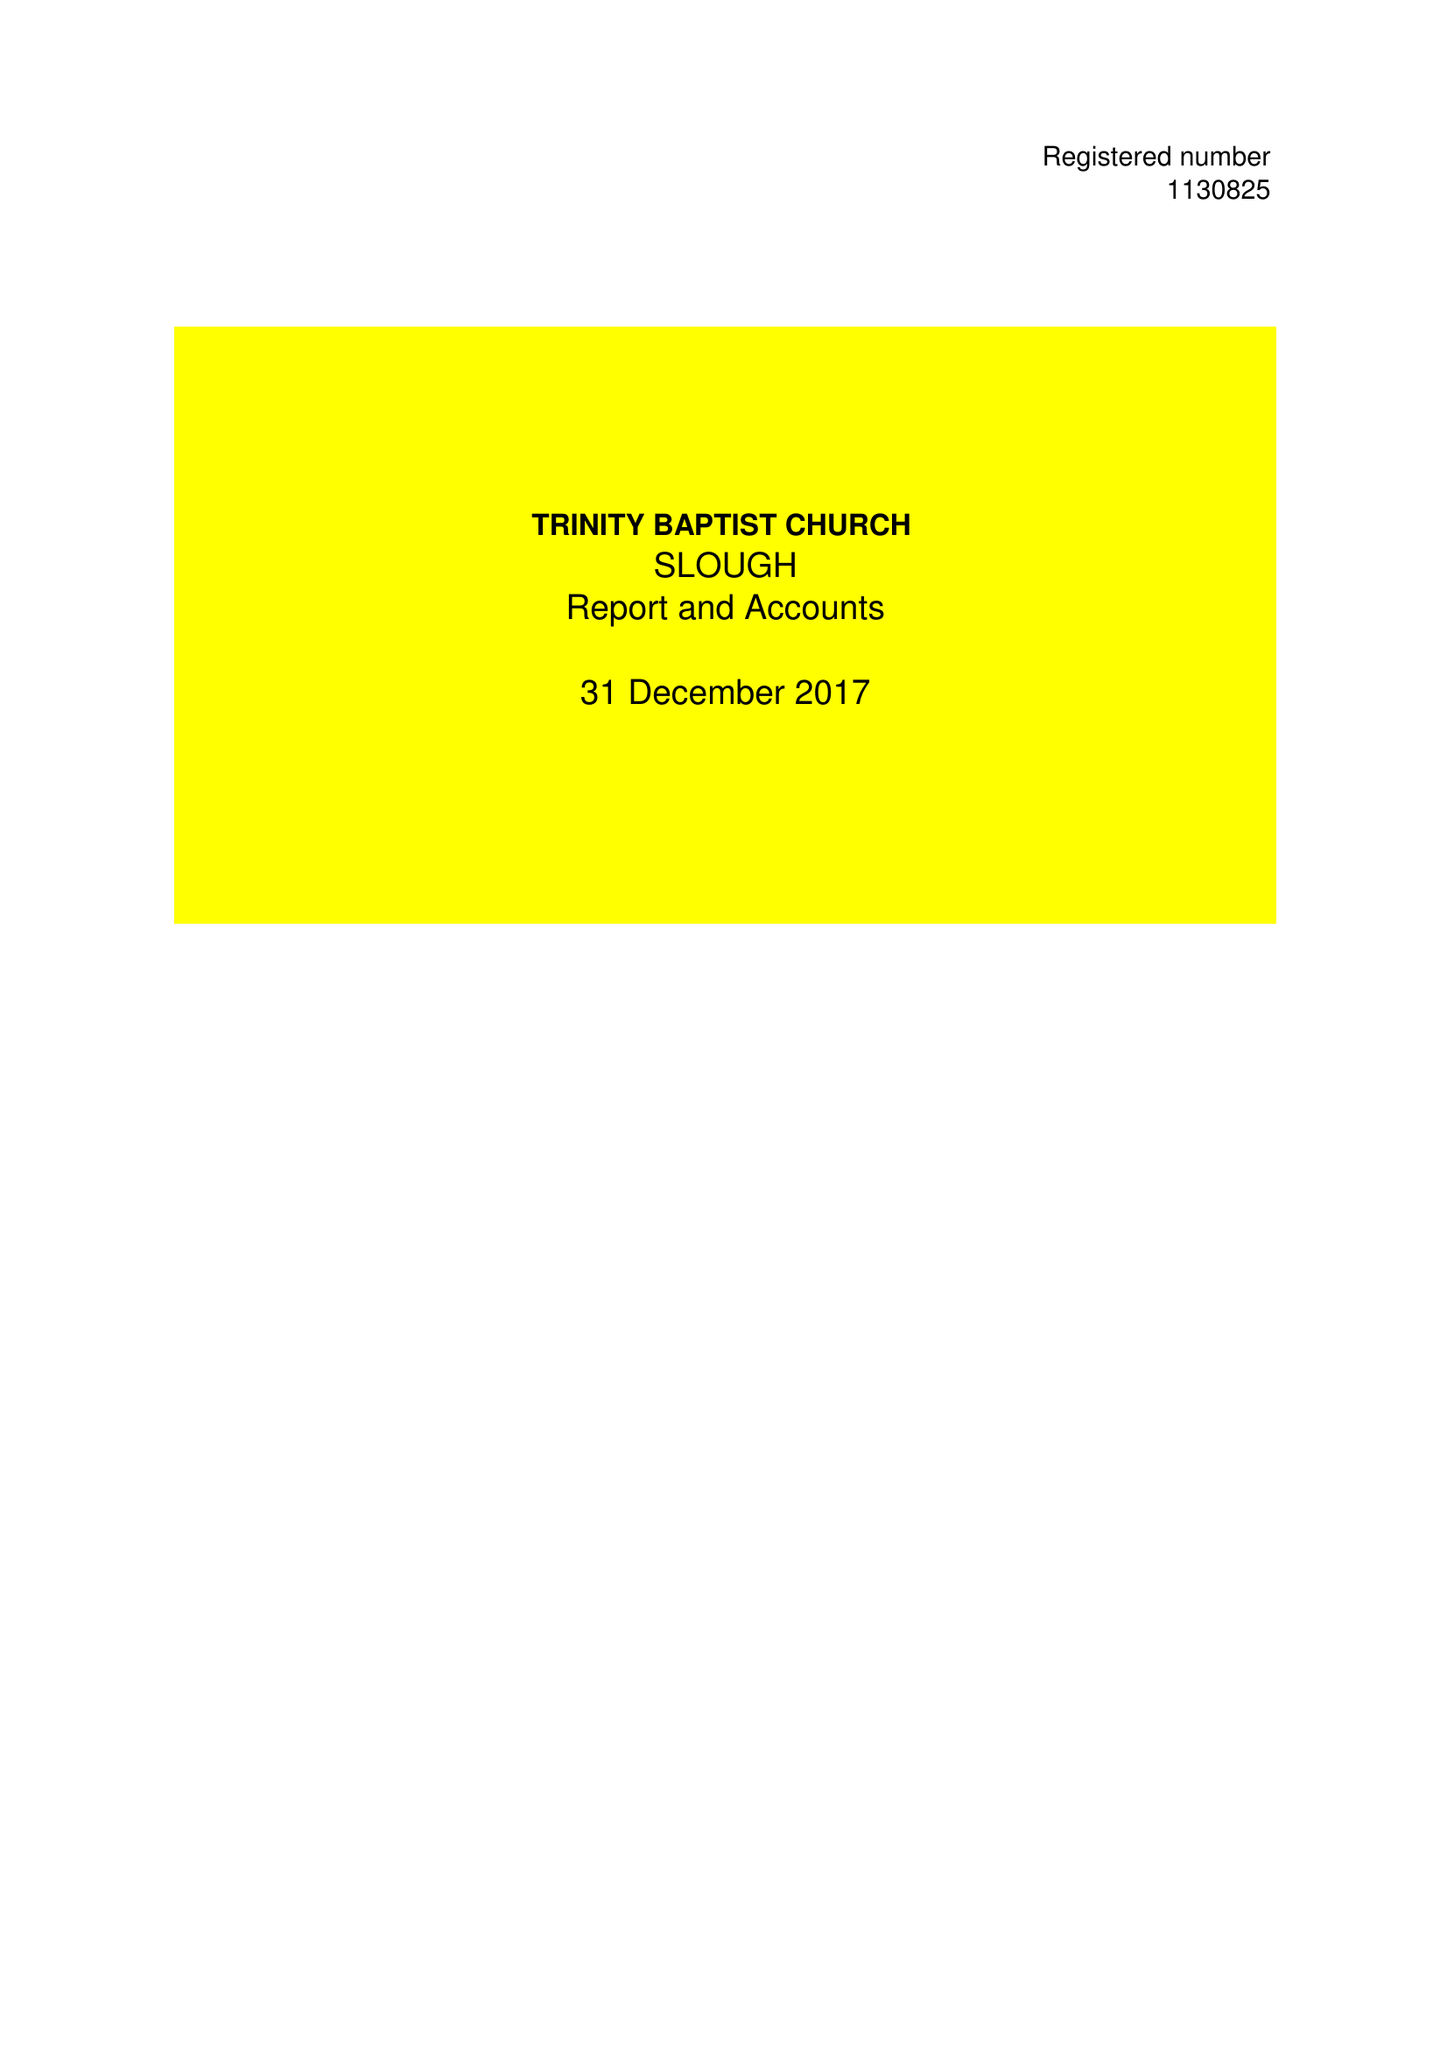What is the value for the address__postcode?
Answer the question using a single word or phrase. CR4 1XH 